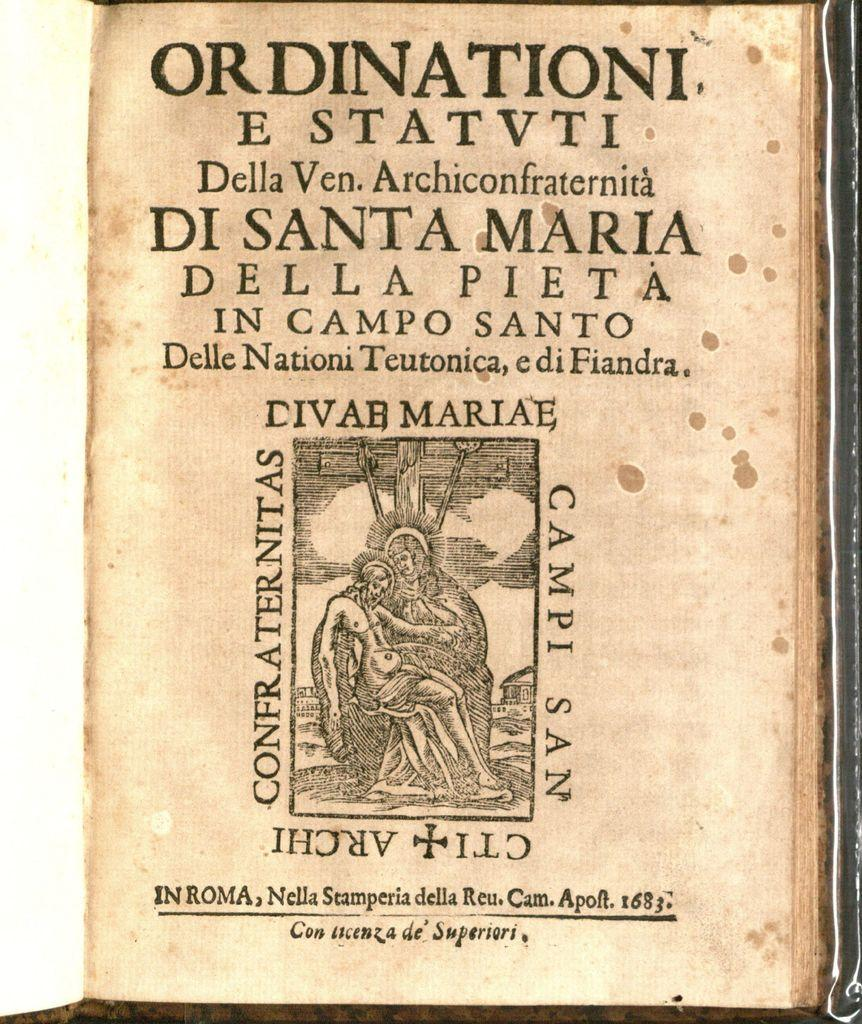<image>
Write a terse but informative summary of the picture. a page that says 'ordinationi e statvti' on the top of it 